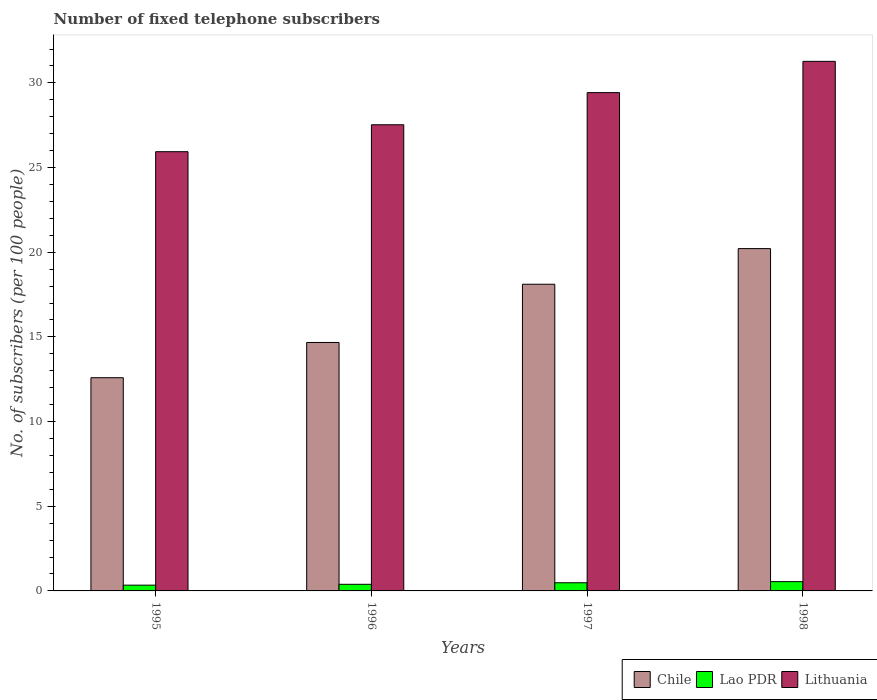How many different coloured bars are there?
Your answer should be very brief. 3. How many bars are there on the 4th tick from the left?
Your answer should be very brief. 3. How many bars are there on the 2nd tick from the right?
Your response must be concise. 3. What is the label of the 3rd group of bars from the left?
Offer a terse response. 1997. In how many cases, is the number of bars for a given year not equal to the number of legend labels?
Keep it short and to the point. 0. What is the number of fixed telephone subscribers in Lithuania in 1995?
Provide a succinct answer. 25.94. Across all years, what is the maximum number of fixed telephone subscribers in Lao PDR?
Keep it short and to the point. 0.55. Across all years, what is the minimum number of fixed telephone subscribers in Lithuania?
Make the answer very short. 25.94. In which year was the number of fixed telephone subscribers in Lithuania minimum?
Offer a terse response. 1995. What is the total number of fixed telephone subscribers in Chile in the graph?
Make the answer very short. 65.58. What is the difference between the number of fixed telephone subscribers in Chile in 1995 and that in 1996?
Keep it short and to the point. -2.08. What is the difference between the number of fixed telephone subscribers in Lao PDR in 1998 and the number of fixed telephone subscribers in Chile in 1996?
Ensure brevity in your answer.  -14.12. What is the average number of fixed telephone subscribers in Chile per year?
Offer a terse response. 16.4. In the year 1995, what is the difference between the number of fixed telephone subscribers in Lao PDR and number of fixed telephone subscribers in Lithuania?
Your response must be concise. -25.6. In how many years, is the number of fixed telephone subscribers in Chile greater than 25?
Offer a terse response. 0. What is the ratio of the number of fixed telephone subscribers in Lithuania in 1996 to that in 1998?
Provide a succinct answer. 0.88. Is the number of fixed telephone subscribers in Lao PDR in 1996 less than that in 1998?
Give a very brief answer. Yes. Is the difference between the number of fixed telephone subscribers in Lao PDR in 1995 and 1998 greater than the difference between the number of fixed telephone subscribers in Lithuania in 1995 and 1998?
Your answer should be compact. Yes. What is the difference between the highest and the second highest number of fixed telephone subscribers in Lithuania?
Offer a terse response. 1.85. What is the difference between the highest and the lowest number of fixed telephone subscribers in Chile?
Your response must be concise. 7.62. Is the sum of the number of fixed telephone subscribers in Lithuania in 1995 and 1997 greater than the maximum number of fixed telephone subscribers in Chile across all years?
Ensure brevity in your answer.  Yes. What does the 3rd bar from the left in 1997 represents?
Provide a succinct answer. Lithuania. What does the 1st bar from the right in 1996 represents?
Ensure brevity in your answer.  Lithuania. How many bars are there?
Provide a succinct answer. 12. Are all the bars in the graph horizontal?
Give a very brief answer. No. How many years are there in the graph?
Offer a terse response. 4. What is the difference between two consecutive major ticks on the Y-axis?
Your response must be concise. 5. How are the legend labels stacked?
Your response must be concise. Horizontal. What is the title of the graph?
Your answer should be compact. Number of fixed telephone subscribers. What is the label or title of the Y-axis?
Offer a terse response. No. of subscribers (per 100 people). What is the No. of subscribers (per 100 people) in Chile in 1995?
Provide a short and direct response. 12.59. What is the No. of subscribers (per 100 people) in Lao PDR in 1995?
Provide a succinct answer. 0.34. What is the No. of subscribers (per 100 people) of Lithuania in 1995?
Provide a succinct answer. 25.94. What is the No. of subscribers (per 100 people) of Chile in 1996?
Your answer should be compact. 14.67. What is the No. of subscribers (per 100 people) of Lao PDR in 1996?
Ensure brevity in your answer.  0.39. What is the No. of subscribers (per 100 people) of Lithuania in 1996?
Make the answer very short. 27.53. What is the No. of subscribers (per 100 people) in Chile in 1997?
Offer a very short reply. 18.11. What is the No. of subscribers (per 100 people) of Lao PDR in 1997?
Provide a short and direct response. 0.48. What is the No. of subscribers (per 100 people) of Lithuania in 1997?
Make the answer very short. 29.42. What is the No. of subscribers (per 100 people) of Chile in 1998?
Ensure brevity in your answer.  20.21. What is the No. of subscribers (per 100 people) in Lao PDR in 1998?
Provide a succinct answer. 0.55. What is the No. of subscribers (per 100 people) in Lithuania in 1998?
Make the answer very short. 31.27. Across all years, what is the maximum No. of subscribers (per 100 people) of Chile?
Ensure brevity in your answer.  20.21. Across all years, what is the maximum No. of subscribers (per 100 people) in Lao PDR?
Make the answer very short. 0.55. Across all years, what is the maximum No. of subscribers (per 100 people) of Lithuania?
Your answer should be compact. 31.27. Across all years, what is the minimum No. of subscribers (per 100 people) of Chile?
Your response must be concise. 12.59. Across all years, what is the minimum No. of subscribers (per 100 people) in Lao PDR?
Provide a short and direct response. 0.34. Across all years, what is the minimum No. of subscribers (per 100 people) of Lithuania?
Your answer should be compact. 25.94. What is the total No. of subscribers (per 100 people) in Chile in the graph?
Your answer should be very brief. 65.58. What is the total No. of subscribers (per 100 people) of Lao PDR in the graph?
Give a very brief answer. 1.76. What is the total No. of subscribers (per 100 people) in Lithuania in the graph?
Your answer should be compact. 114.16. What is the difference between the No. of subscribers (per 100 people) in Chile in 1995 and that in 1996?
Provide a short and direct response. -2.08. What is the difference between the No. of subscribers (per 100 people) in Lao PDR in 1995 and that in 1996?
Make the answer very short. -0.05. What is the difference between the No. of subscribers (per 100 people) of Lithuania in 1995 and that in 1996?
Your answer should be compact. -1.59. What is the difference between the No. of subscribers (per 100 people) in Chile in 1995 and that in 1997?
Provide a succinct answer. -5.52. What is the difference between the No. of subscribers (per 100 people) in Lao PDR in 1995 and that in 1997?
Your response must be concise. -0.14. What is the difference between the No. of subscribers (per 100 people) of Lithuania in 1995 and that in 1997?
Offer a terse response. -3.49. What is the difference between the No. of subscribers (per 100 people) of Chile in 1995 and that in 1998?
Offer a terse response. -7.62. What is the difference between the No. of subscribers (per 100 people) in Lao PDR in 1995 and that in 1998?
Your answer should be compact. -0.21. What is the difference between the No. of subscribers (per 100 people) of Lithuania in 1995 and that in 1998?
Your answer should be compact. -5.34. What is the difference between the No. of subscribers (per 100 people) of Chile in 1996 and that in 1997?
Make the answer very short. -3.44. What is the difference between the No. of subscribers (per 100 people) in Lao PDR in 1996 and that in 1997?
Ensure brevity in your answer.  -0.09. What is the difference between the No. of subscribers (per 100 people) in Lithuania in 1996 and that in 1997?
Provide a succinct answer. -1.9. What is the difference between the No. of subscribers (per 100 people) in Chile in 1996 and that in 1998?
Your response must be concise. -5.54. What is the difference between the No. of subscribers (per 100 people) in Lao PDR in 1996 and that in 1998?
Provide a succinct answer. -0.16. What is the difference between the No. of subscribers (per 100 people) of Lithuania in 1996 and that in 1998?
Offer a very short reply. -3.74. What is the difference between the No. of subscribers (per 100 people) of Chile in 1997 and that in 1998?
Provide a succinct answer. -2.1. What is the difference between the No. of subscribers (per 100 people) in Lao PDR in 1997 and that in 1998?
Your answer should be very brief. -0.07. What is the difference between the No. of subscribers (per 100 people) in Lithuania in 1997 and that in 1998?
Give a very brief answer. -1.85. What is the difference between the No. of subscribers (per 100 people) of Chile in 1995 and the No. of subscribers (per 100 people) of Lao PDR in 1996?
Keep it short and to the point. 12.2. What is the difference between the No. of subscribers (per 100 people) of Chile in 1995 and the No. of subscribers (per 100 people) of Lithuania in 1996?
Ensure brevity in your answer.  -14.94. What is the difference between the No. of subscribers (per 100 people) in Lao PDR in 1995 and the No. of subscribers (per 100 people) in Lithuania in 1996?
Offer a very short reply. -27.19. What is the difference between the No. of subscribers (per 100 people) of Chile in 1995 and the No. of subscribers (per 100 people) of Lao PDR in 1997?
Provide a short and direct response. 12.11. What is the difference between the No. of subscribers (per 100 people) in Chile in 1995 and the No. of subscribers (per 100 people) in Lithuania in 1997?
Provide a short and direct response. -16.83. What is the difference between the No. of subscribers (per 100 people) of Lao PDR in 1995 and the No. of subscribers (per 100 people) of Lithuania in 1997?
Your answer should be compact. -29.08. What is the difference between the No. of subscribers (per 100 people) in Chile in 1995 and the No. of subscribers (per 100 people) in Lao PDR in 1998?
Provide a succinct answer. 12.04. What is the difference between the No. of subscribers (per 100 people) in Chile in 1995 and the No. of subscribers (per 100 people) in Lithuania in 1998?
Make the answer very short. -18.68. What is the difference between the No. of subscribers (per 100 people) of Lao PDR in 1995 and the No. of subscribers (per 100 people) of Lithuania in 1998?
Provide a succinct answer. -30.93. What is the difference between the No. of subscribers (per 100 people) in Chile in 1996 and the No. of subscribers (per 100 people) in Lao PDR in 1997?
Make the answer very short. 14.19. What is the difference between the No. of subscribers (per 100 people) in Chile in 1996 and the No. of subscribers (per 100 people) in Lithuania in 1997?
Make the answer very short. -14.75. What is the difference between the No. of subscribers (per 100 people) in Lao PDR in 1996 and the No. of subscribers (per 100 people) in Lithuania in 1997?
Make the answer very short. -29.03. What is the difference between the No. of subscribers (per 100 people) in Chile in 1996 and the No. of subscribers (per 100 people) in Lao PDR in 1998?
Make the answer very short. 14.12. What is the difference between the No. of subscribers (per 100 people) in Chile in 1996 and the No. of subscribers (per 100 people) in Lithuania in 1998?
Provide a short and direct response. -16.6. What is the difference between the No. of subscribers (per 100 people) in Lao PDR in 1996 and the No. of subscribers (per 100 people) in Lithuania in 1998?
Make the answer very short. -30.88. What is the difference between the No. of subscribers (per 100 people) in Chile in 1997 and the No. of subscribers (per 100 people) in Lao PDR in 1998?
Ensure brevity in your answer.  17.56. What is the difference between the No. of subscribers (per 100 people) of Chile in 1997 and the No. of subscribers (per 100 people) of Lithuania in 1998?
Your answer should be compact. -13.16. What is the difference between the No. of subscribers (per 100 people) in Lao PDR in 1997 and the No. of subscribers (per 100 people) in Lithuania in 1998?
Offer a very short reply. -30.79. What is the average No. of subscribers (per 100 people) in Chile per year?
Your answer should be very brief. 16.4. What is the average No. of subscribers (per 100 people) of Lao PDR per year?
Provide a short and direct response. 0.44. What is the average No. of subscribers (per 100 people) in Lithuania per year?
Your answer should be compact. 28.54. In the year 1995, what is the difference between the No. of subscribers (per 100 people) of Chile and No. of subscribers (per 100 people) of Lao PDR?
Make the answer very short. 12.25. In the year 1995, what is the difference between the No. of subscribers (per 100 people) in Chile and No. of subscribers (per 100 people) in Lithuania?
Provide a succinct answer. -13.35. In the year 1995, what is the difference between the No. of subscribers (per 100 people) in Lao PDR and No. of subscribers (per 100 people) in Lithuania?
Provide a short and direct response. -25.6. In the year 1996, what is the difference between the No. of subscribers (per 100 people) in Chile and No. of subscribers (per 100 people) in Lao PDR?
Ensure brevity in your answer.  14.28. In the year 1996, what is the difference between the No. of subscribers (per 100 people) of Chile and No. of subscribers (per 100 people) of Lithuania?
Your answer should be compact. -12.86. In the year 1996, what is the difference between the No. of subscribers (per 100 people) in Lao PDR and No. of subscribers (per 100 people) in Lithuania?
Your answer should be very brief. -27.14. In the year 1997, what is the difference between the No. of subscribers (per 100 people) of Chile and No. of subscribers (per 100 people) of Lao PDR?
Ensure brevity in your answer.  17.63. In the year 1997, what is the difference between the No. of subscribers (per 100 people) in Chile and No. of subscribers (per 100 people) in Lithuania?
Ensure brevity in your answer.  -11.32. In the year 1997, what is the difference between the No. of subscribers (per 100 people) in Lao PDR and No. of subscribers (per 100 people) in Lithuania?
Ensure brevity in your answer.  -28.94. In the year 1998, what is the difference between the No. of subscribers (per 100 people) in Chile and No. of subscribers (per 100 people) in Lao PDR?
Make the answer very short. 19.67. In the year 1998, what is the difference between the No. of subscribers (per 100 people) of Chile and No. of subscribers (per 100 people) of Lithuania?
Your answer should be compact. -11.06. In the year 1998, what is the difference between the No. of subscribers (per 100 people) of Lao PDR and No. of subscribers (per 100 people) of Lithuania?
Provide a short and direct response. -30.72. What is the ratio of the No. of subscribers (per 100 people) in Chile in 1995 to that in 1996?
Keep it short and to the point. 0.86. What is the ratio of the No. of subscribers (per 100 people) in Lao PDR in 1995 to that in 1996?
Ensure brevity in your answer.  0.87. What is the ratio of the No. of subscribers (per 100 people) in Lithuania in 1995 to that in 1996?
Give a very brief answer. 0.94. What is the ratio of the No. of subscribers (per 100 people) of Chile in 1995 to that in 1997?
Provide a short and direct response. 0.7. What is the ratio of the No. of subscribers (per 100 people) in Lao PDR in 1995 to that in 1997?
Your answer should be very brief. 0.71. What is the ratio of the No. of subscribers (per 100 people) of Lithuania in 1995 to that in 1997?
Offer a very short reply. 0.88. What is the ratio of the No. of subscribers (per 100 people) in Chile in 1995 to that in 1998?
Your answer should be very brief. 0.62. What is the ratio of the No. of subscribers (per 100 people) of Lao PDR in 1995 to that in 1998?
Make the answer very short. 0.62. What is the ratio of the No. of subscribers (per 100 people) in Lithuania in 1995 to that in 1998?
Offer a terse response. 0.83. What is the ratio of the No. of subscribers (per 100 people) of Chile in 1996 to that in 1997?
Make the answer very short. 0.81. What is the ratio of the No. of subscribers (per 100 people) in Lao PDR in 1996 to that in 1997?
Provide a short and direct response. 0.81. What is the ratio of the No. of subscribers (per 100 people) of Lithuania in 1996 to that in 1997?
Offer a very short reply. 0.94. What is the ratio of the No. of subscribers (per 100 people) of Chile in 1996 to that in 1998?
Your response must be concise. 0.73. What is the ratio of the No. of subscribers (per 100 people) of Lao PDR in 1996 to that in 1998?
Ensure brevity in your answer.  0.71. What is the ratio of the No. of subscribers (per 100 people) in Lithuania in 1996 to that in 1998?
Your answer should be compact. 0.88. What is the ratio of the No. of subscribers (per 100 people) in Chile in 1997 to that in 1998?
Your answer should be very brief. 0.9. What is the ratio of the No. of subscribers (per 100 people) in Lao PDR in 1997 to that in 1998?
Make the answer very short. 0.88. What is the ratio of the No. of subscribers (per 100 people) of Lithuania in 1997 to that in 1998?
Give a very brief answer. 0.94. What is the difference between the highest and the second highest No. of subscribers (per 100 people) of Chile?
Keep it short and to the point. 2.1. What is the difference between the highest and the second highest No. of subscribers (per 100 people) of Lao PDR?
Ensure brevity in your answer.  0.07. What is the difference between the highest and the second highest No. of subscribers (per 100 people) of Lithuania?
Your response must be concise. 1.85. What is the difference between the highest and the lowest No. of subscribers (per 100 people) in Chile?
Offer a terse response. 7.62. What is the difference between the highest and the lowest No. of subscribers (per 100 people) in Lao PDR?
Make the answer very short. 0.21. What is the difference between the highest and the lowest No. of subscribers (per 100 people) in Lithuania?
Provide a succinct answer. 5.34. 